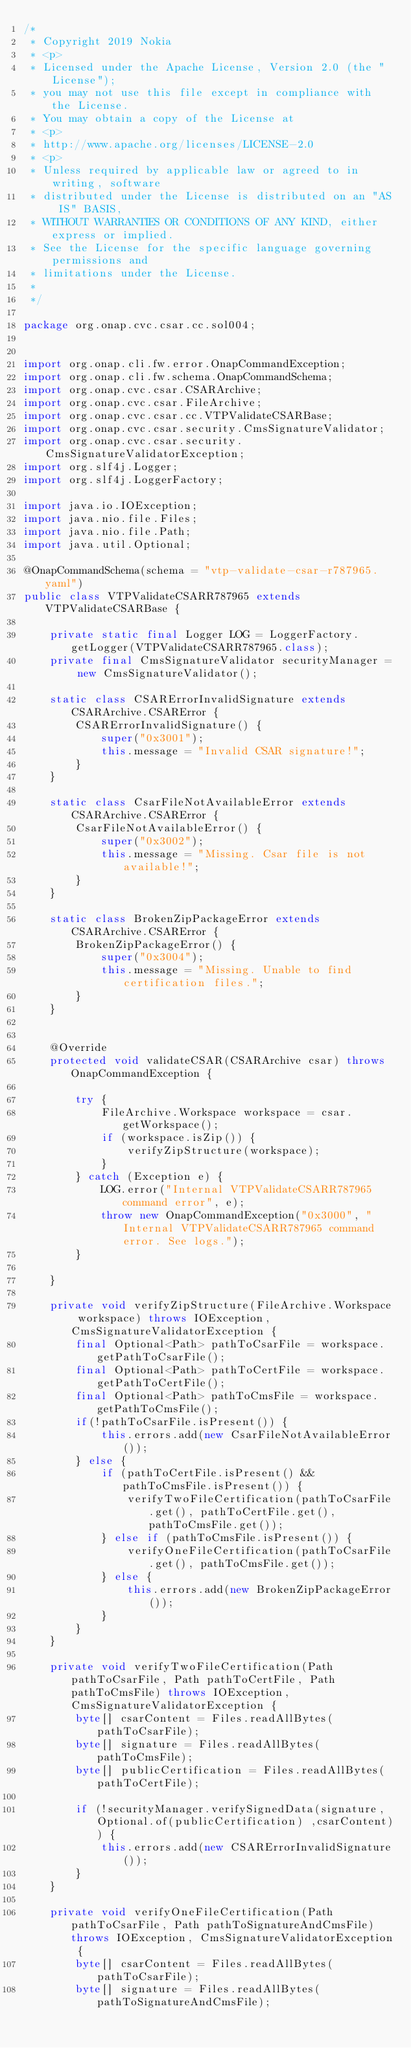Convert code to text. <code><loc_0><loc_0><loc_500><loc_500><_Java_>/*
 * Copyright 2019 Nokia
 * <p>
 * Licensed under the Apache License, Version 2.0 (the "License");
 * you may not use this file except in compliance with the License.
 * You may obtain a copy of the License at
 * <p>
 * http://www.apache.org/licenses/LICENSE-2.0
 * <p>
 * Unless required by applicable law or agreed to in writing, software
 * distributed under the License is distributed on an "AS IS" BASIS,
 * WITHOUT WARRANTIES OR CONDITIONS OF ANY KIND, either express or implied.
 * See the License for the specific language governing permissions and
 * limitations under the License.
 *
 */

package org.onap.cvc.csar.cc.sol004;


import org.onap.cli.fw.error.OnapCommandException;
import org.onap.cli.fw.schema.OnapCommandSchema;
import org.onap.cvc.csar.CSARArchive;
import org.onap.cvc.csar.FileArchive;
import org.onap.cvc.csar.cc.VTPValidateCSARBase;
import org.onap.cvc.csar.security.CmsSignatureValidator;
import org.onap.cvc.csar.security.CmsSignatureValidatorException;
import org.slf4j.Logger;
import org.slf4j.LoggerFactory;

import java.io.IOException;
import java.nio.file.Files;
import java.nio.file.Path;
import java.util.Optional;

@OnapCommandSchema(schema = "vtp-validate-csar-r787965.yaml")
public class VTPValidateCSARR787965 extends VTPValidateCSARBase {

    private static final Logger LOG = LoggerFactory.getLogger(VTPValidateCSARR787965.class);
    private final CmsSignatureValidator securityManager = new CmsSignatureValidator();

    static class CSARErrorInvalidSignature extends CSARArchive.CSARError {
        CSARErrorInvalidSignature() {
            super("0x3001");
            this.message = "Invalid CSAR signature!";
        }
    }

    static class CsarFileNotAvailableError extends CSARArchive.CSARError {
        CsarFileNotAvailableError() {
            super("0x3002");
            this.message = "Missing. Csar file is not available!";
        }
    }

    static class BrokenZipPackageError extends CSARArchive.CSARError {
        BrokenZipPackageError() {
            super("0x3004");
            this.message = "Missing. Unable to find certification files.";
        }
    }


    @Override
    protected void validateCSAR(CSARArchive csar) throws OnapCommandException {

        try {
            FileArchive.Workspace workspace = csar.getWorkspace();
            if (workspace.isZip()) {
                verifyZipStructure(workspace);
            }
        } catch (Exception e) {
            LOG.error("Internal VTPValidateCSARR787965 command error", e);
            throw new OnapCommandException("0x3000", "Internal VTPValidateCSARR787965 command error. See logs.");
        }

    }

    private void verifyZipStructure(FileArchive.Workspace workspace) throws IOException, CmsSignatureValidatorException {
        final Optional<Path> pathToCsarFile = workspace.getPathToCsarFile();
        final Optional<Path> pathToCertFile = workspace.getPathToCertFile();
        final Optional<Path> pathToCmsFile = workspace.getPathToCmsFile();
        if(!pathToCsarFile.isPresent()) {
            this.errors.add(new CsarFileNotAvailableError());
        } else {
            if (pathToCertFile.isPresent() && pathToCmsFile.isPresent()) {
                verifyTwoFileCertification(pathToCsarFile.get(), pathToCertFile.get(), pathToCmsFile.get());
            } else if (pathToCmsFile.isPresent()) {
                verifyOneFileCertification(pathToCsarFile.get(), pathToCmsFile.get());
            } else {
                this.errors.add(new BrokenZipPackageError());
            }
        }
    }

    private void verifyTwoFileCertification(Path pathToCsarFile, Path pathToCertFile, Path pathToCmsFile) throws IOException, CmsSignatureValidatorException {
        byte[] csarContent = Files.readAllBytes(pathToCsarFile);
        byte[] signature = Files.readAllBytes(pathToCmsFile);
        byte[] publicCertification = Files.readAllBytes(pathToCertFile);

        if (!securityManager.verifySignedData(signature, Optional.of(publicCertification) ,csarContent)) {
            this.errors.add(new CSARErrorInvalidSignature());
        }
    }

    private void verifyOneFileCertification(Path pathToCsarFile, Path pathToSignatureAndCmsFile) throws IOException, CmsSignatureValidatorException {
        byte[] csarContent = Files.readAllBytes(pathToCsarFile);
        byte[] signature = Files.readAllBytes(pathToSignatureAndCmsFile);
</code> 